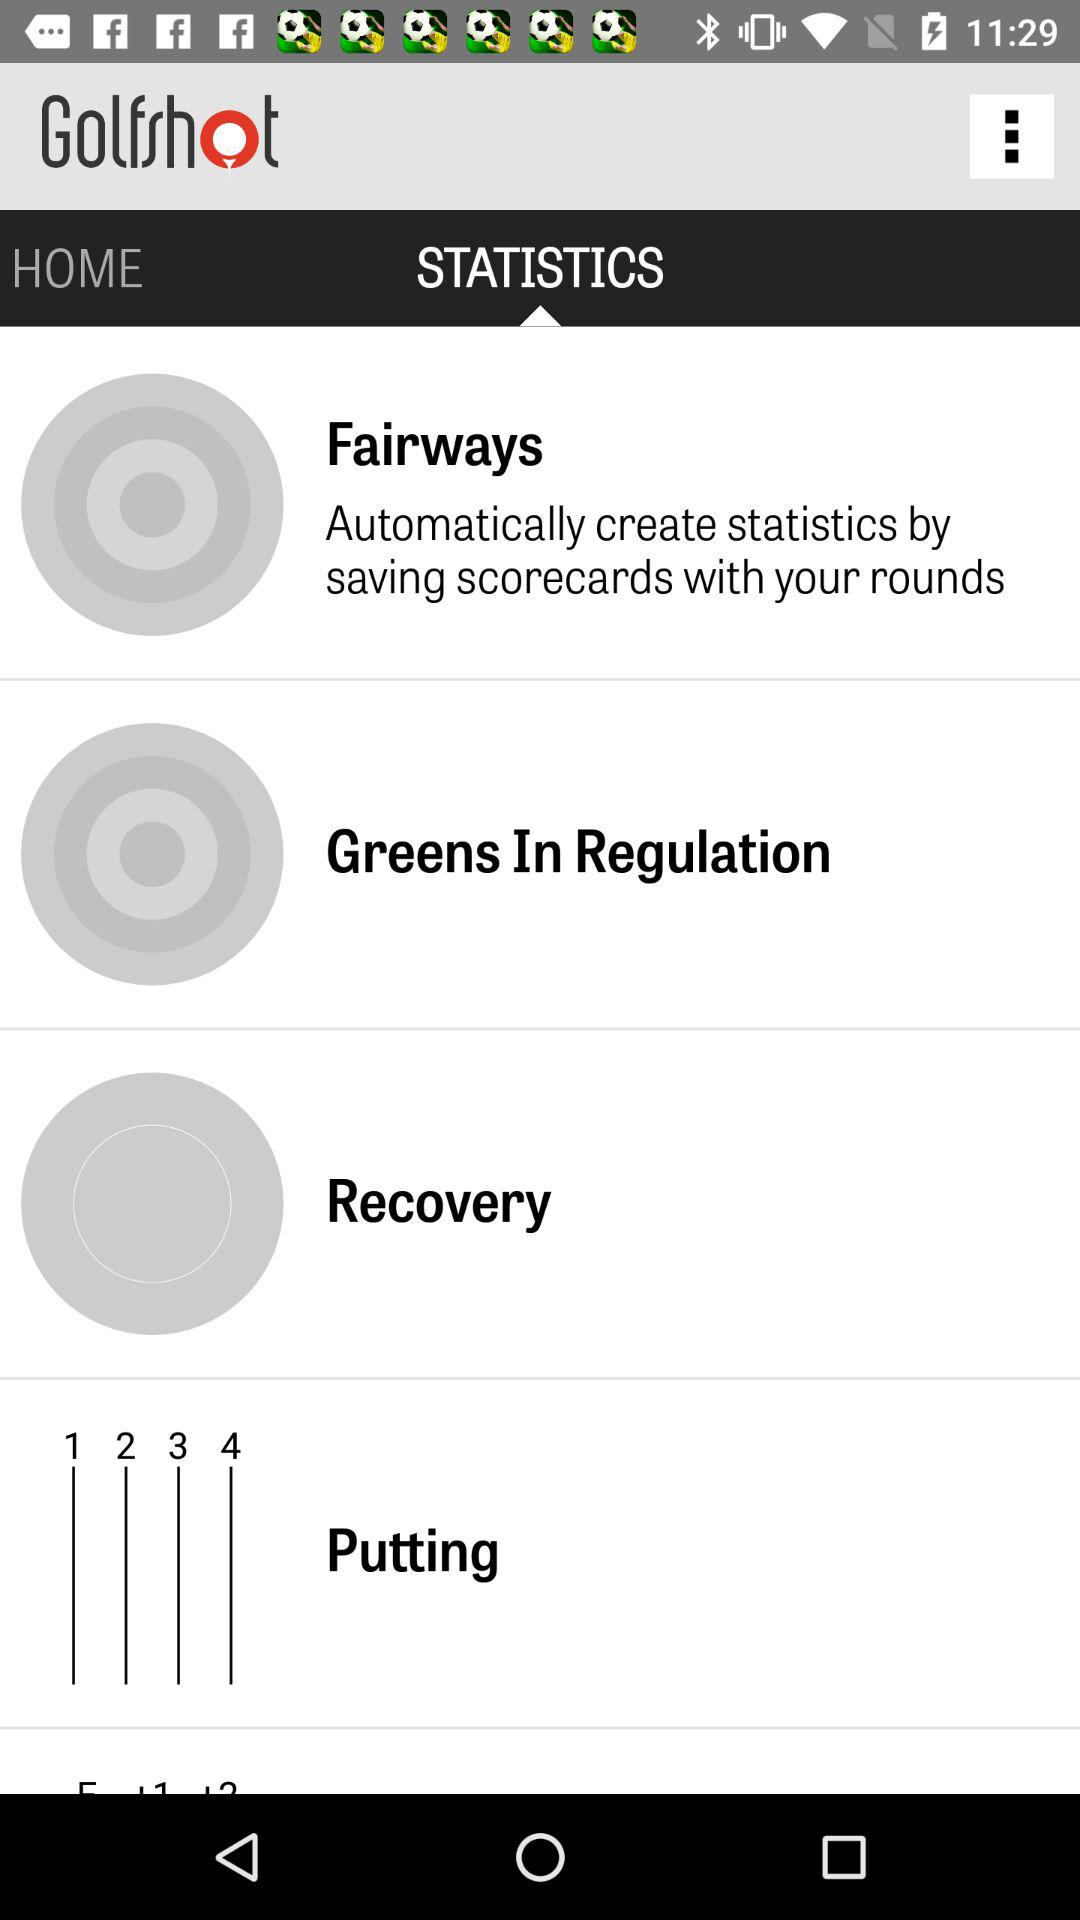Which tab am I on?
Answer the question using a single word or phrase. The tab is "STATISTICS." 